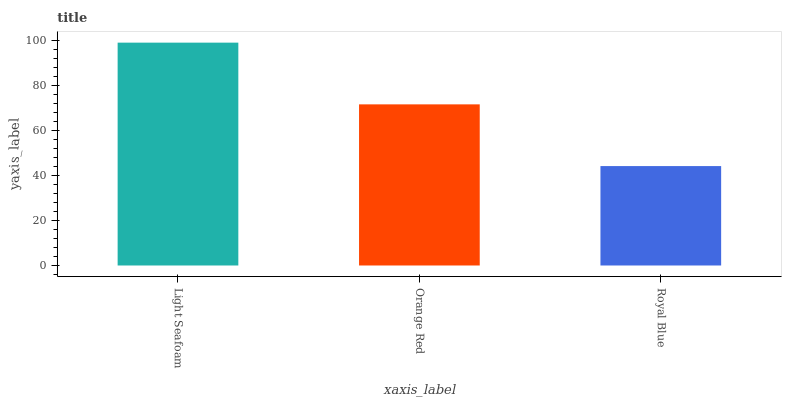Is Royal Blue the minimum?
Answer yes or no. Yes. Is Light Seafoam the maximum?
Answer yes or no. Yes. Is Orange Red the minimum?
Answer yes or no. No. Is Orange Red the maximum?
Answer yes or no. No. Is Light Seafoam greater than Orange Red?
Answer yes or no. Yes. Is Orange Red less than Light Seafoam?
Answer yes or no. Yes. Is Orange Red greater than Light Seafoam?
Answer yes or no. No. Is Light Seafoam less than Orange Red?
Answer yes or no. No. Is Orange Red the high median?
Answer yes or no. Yes. Is Orange Red the low median?
Answer yes or no. Yes. Is Royal Blue the high median?
Answer yes or no. No. Is Light Seafoam the low median?
Answer yes or no. No. 